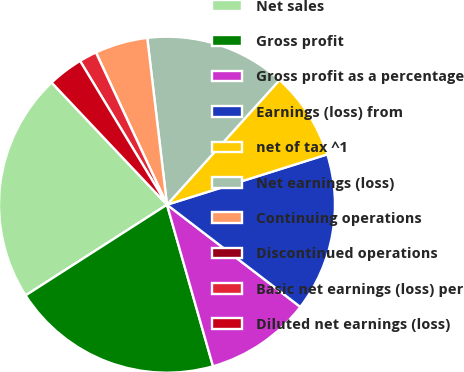<chart> <loc_0><loc_0><loc_500><loc_500><pie_chart><fcel>Net sales<fcel>Gross profit<fcel>Gross profit as a percentage<fcel>Earnings (loss) from<fcel>net of tax ^1<fcel>Net earnings (loss)<fcel>Continuing operations<fcel>Discontinued operations<fcel>Basic net earnings (loss) per<fcel>Diluted net earnings (loss)<nl><fcel>22.03%<fcel>20.34%<fcel>10.17%<fcel>15.25%<fcel>8.47%<fcel>13.56%<fcel>5.08%<fcel>0.0%<fcel>1.7%<fcel>3.39%<nl></chart> 